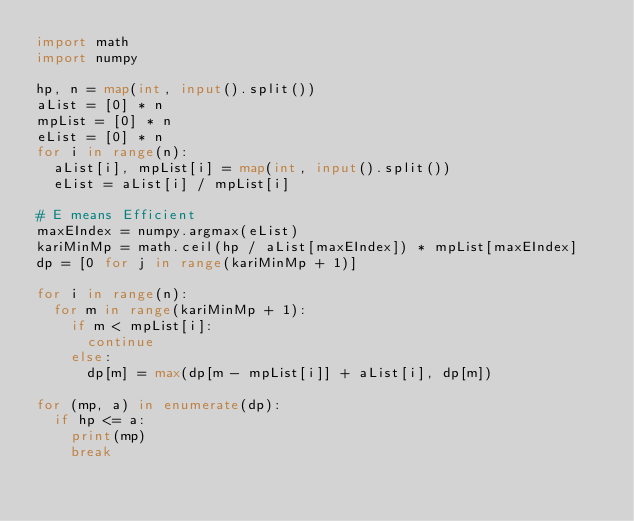Convert code to text. <code><loc_0><loc_0><loc_500><loc_500><_Python_>import math
import numpy

hp, n = map(int, input().split())
aList = [0] * n
mpList = [0] * n
eList = [0] * n
for i in range(n):
  aList[i], mpList[i] = map(int, input().split())
  eList = aList[i] / mpList[i]

# E means Efficient
maxEIndex = numpy.argmax(eList)
kariMinMp = math.ceil(hp / aList[maxEIndex]) * mpList[maxEIndex]
dp = [0 for j in range(kariMinMp + 1)]

for i in range(n):
  for m in range(kariMinMp + 1):
    if m < mpList[i]:
      continue
    else:
      dp[m] = max(dp[m - mpList[i]] + aList[i], dp[m])

for (mp, a) in enumerate(dp):
  if hp <= a:
    print(mp)
    break
</code> 